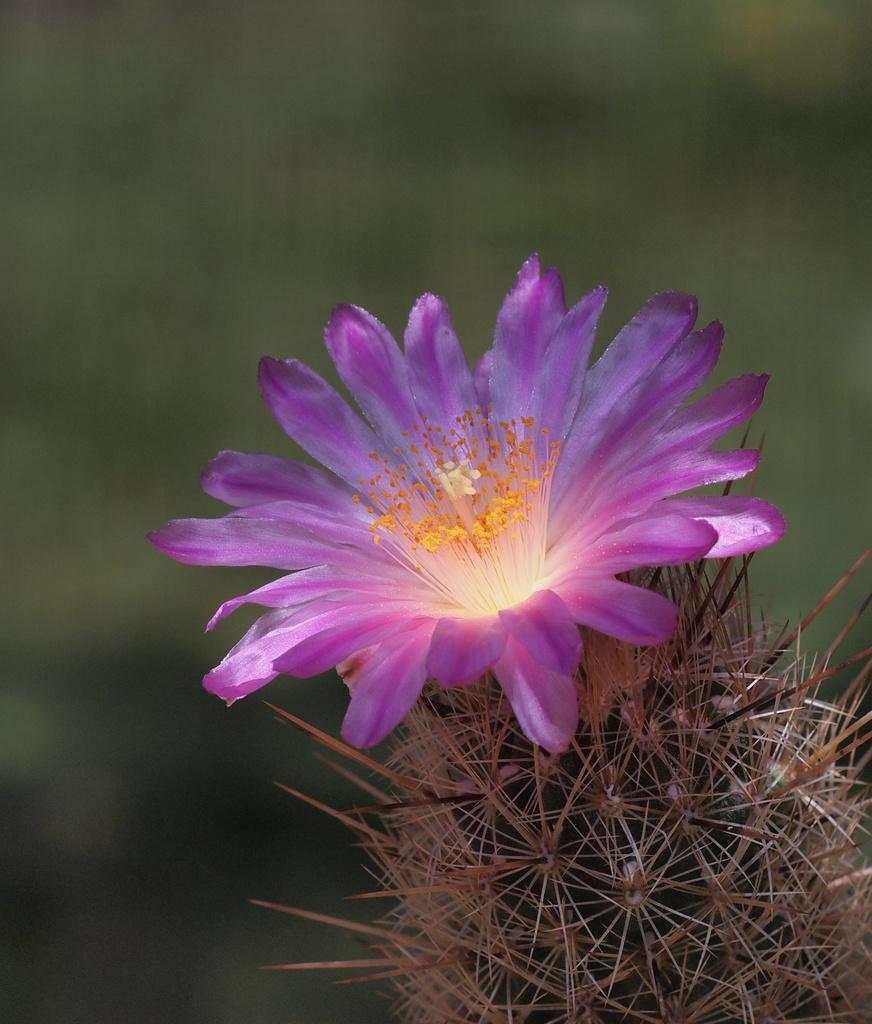Describe this image in one or two sentences. In this picture we can see a plant with a flower and in the background it is blurry. 